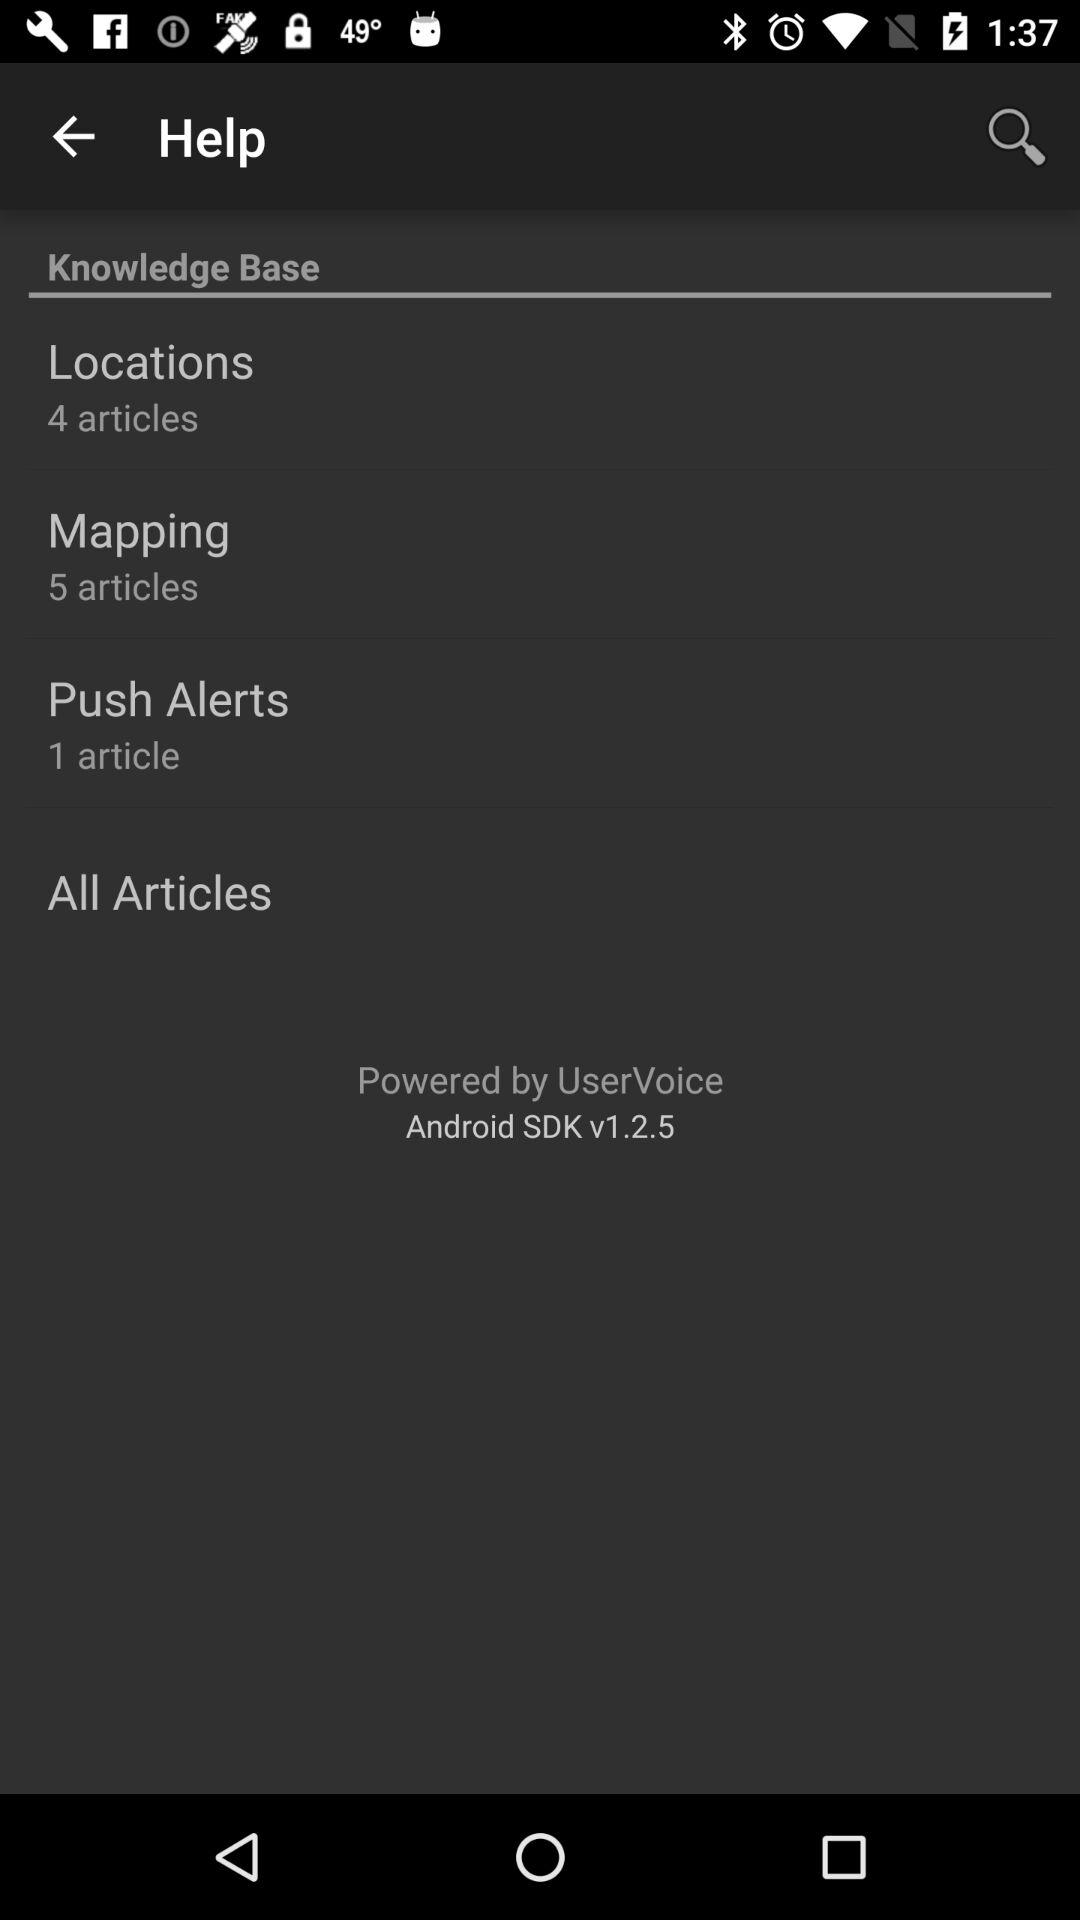What can you infer about the application using this help menu? From the help menu, it can be inferred that the application likely has mapping and location features, as indicated by the specific sections in the knowledge base. It also seems to offer push notifications, noting the 'Push Alerts' section. This menu provides targeted support to users requiring assistance with these functionalities. 